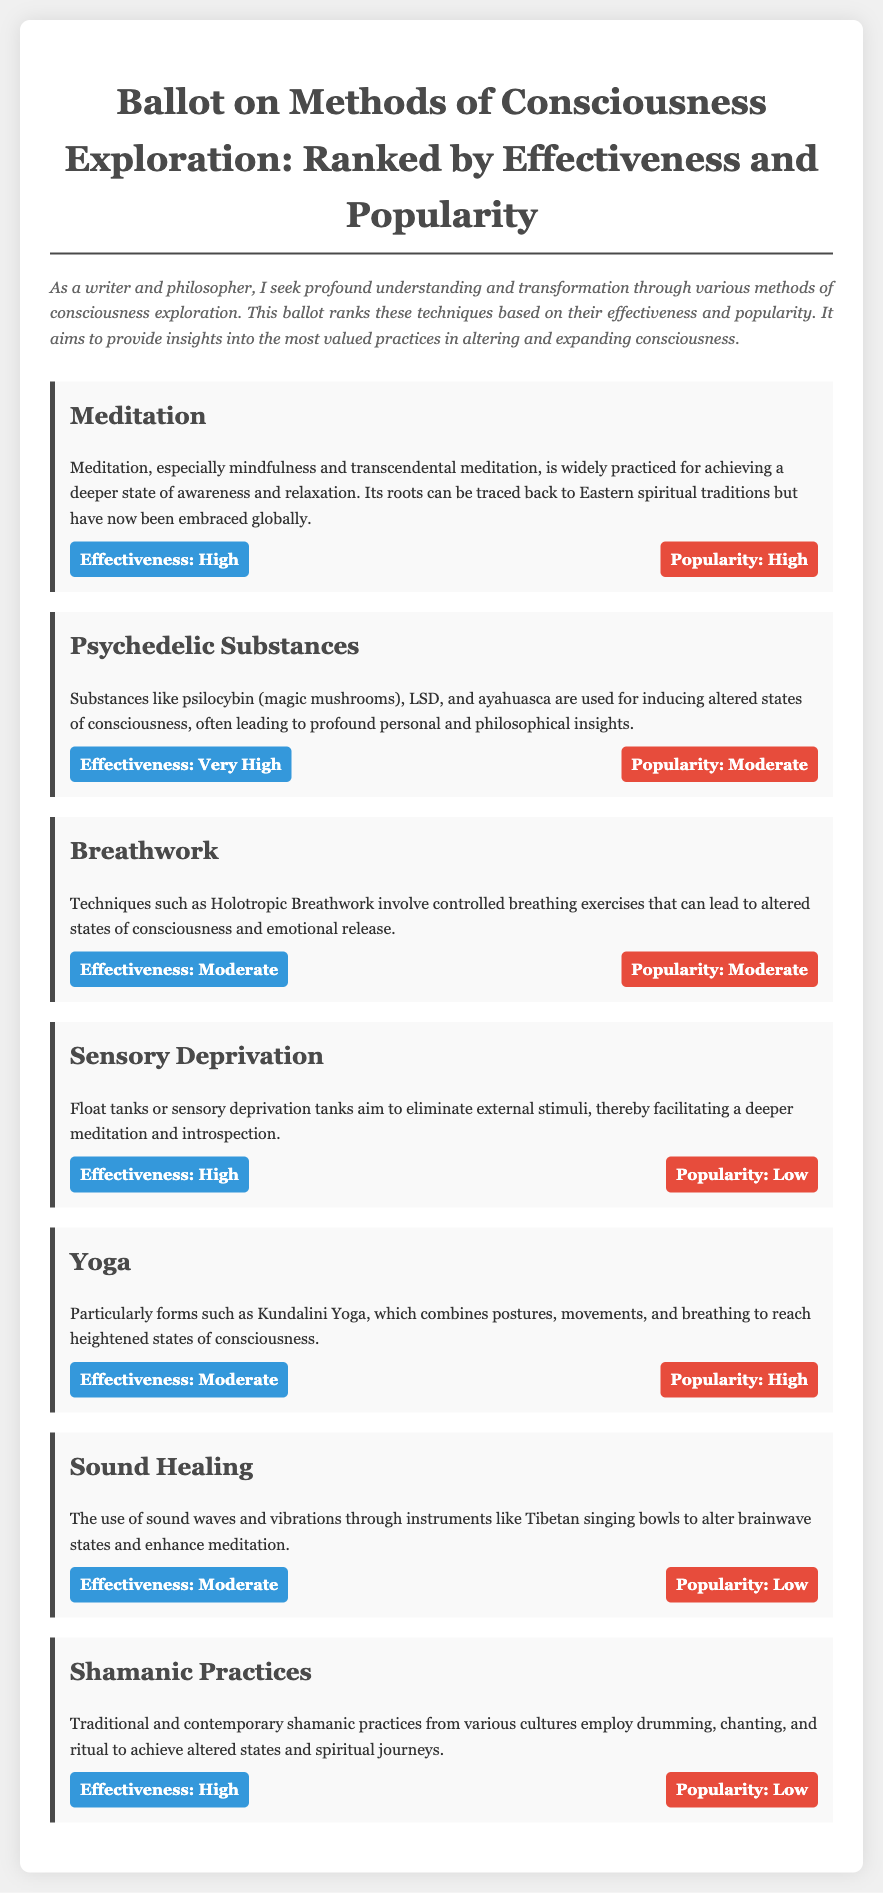what is the title of the ballot? The title is presented prominently at the top of the document, highlighting the focus on consciousness exploration methods.
Answer: Ballot on Methods of Consciousness Exploration: Ranked by Effectiveness and Popularity how many methods are listed in the document? The document details a total of seven methods of consciousness exploration presented in separate sections.
Answer: Seven which method has the highest effectiveness rating? The method with the highest effectiveness rating is identified clearly in its rating section, indicating its superiority in this regard.
Answer: Psychedelic Substances what is the popularity rating of Sensory Deprivation? The popularity of Sensory Deprivation is specified along with its effectiveness, providing insights into its acceptance among practitioners.
Answer: Low which two methods share a moderate popularity rating? The popularity ratings for multiple methods are provided; two methods have the same moderate rating across the document.
Answer: Breathwork, Yoga what statement describes the effectiveness of Sound Healing? The document briefly characterizes the effectiveness of Sound Healing, allowing for quick understanding of its significance.
Answer: Moderate what is the effectiveness rating of Meditation? The effectiveness of Meditation is explicitly rated, showcasing its perceived value in consciousness exploration.
Answer: High which method combines postures and movements for consciousness exploration? A specific method is described as involving physical postures and movements for achieving heightened consciousness, offering a unique approach.
Answer: Yoga 